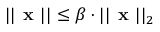Convert formula to latex. <formula><loc_0><loc_0><loc_500><loc_500>| | { x } | | \leq \beta \cdot | | { x } | | _ { 2 }</formula> 